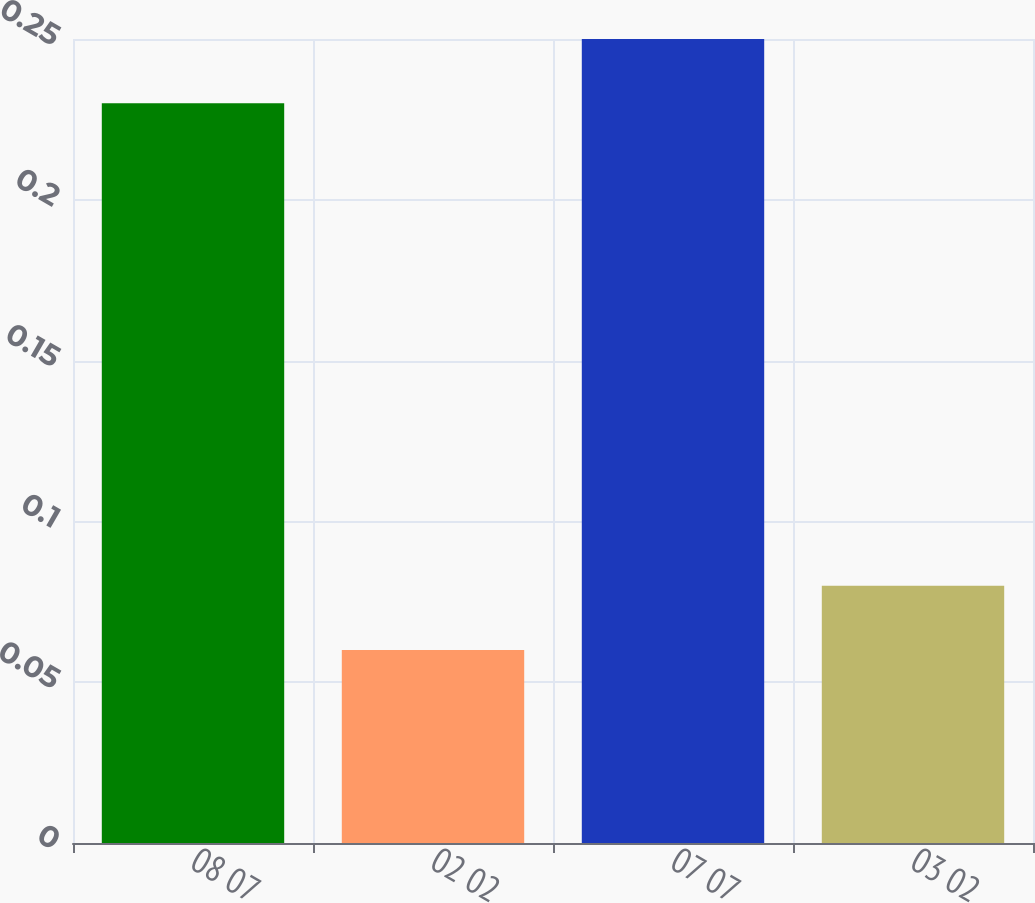Convert chart to OTSL. <chart><loc_0><loc_0><loc_500><loc_500><bar_chart><fcel>08 07<fcel>02 02<fcel>07 07<fcel>03 02<nl><fcel>0.23<fcel>0.06<fcel>0.25<fcel>0.08<nl></chart> 